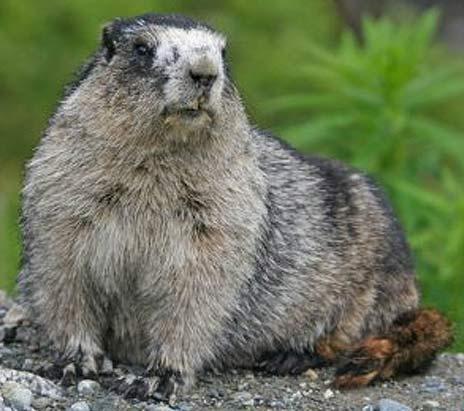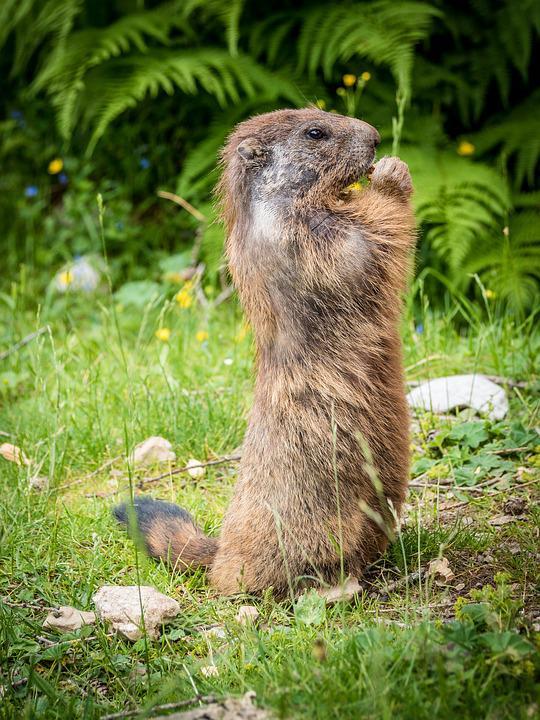The first image is the image on the left, the second image is the image on the right. Evaluate the accuracy of this statement regarding the images: "The marmot in the left image is upright with food clasped in its paws, and the marmot on the right is standing on all fours on the ground.". Is it true? Answer yes or no. No. The first image is the image on the left, the second image is the image on the right. Assess this claim about the two images: "The animal in the image on the left is holding something to its mouth.". Correct or not? Answer yes or no. No. 